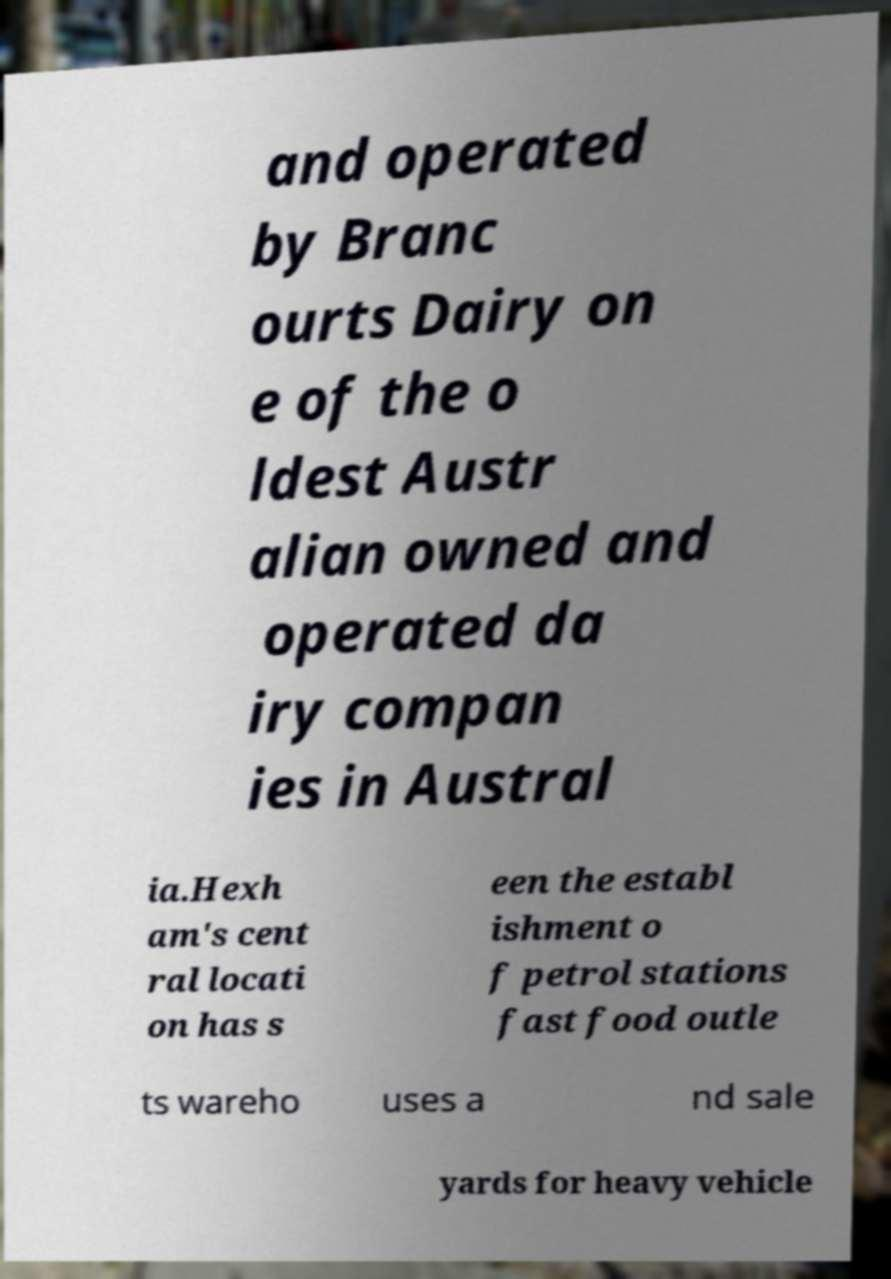Could you assist in decoding the text presented in this image and type it out clearly? and operated by Branc ourts Dairy on e of the o ldest Austr alian owned and operated da iry compan ies in Austral ia.Hexh am's cent ral locati on has s een the establ ishment o f petrol stations fast food outle ts wareho uses a nd sale yards for heavy vehicle 